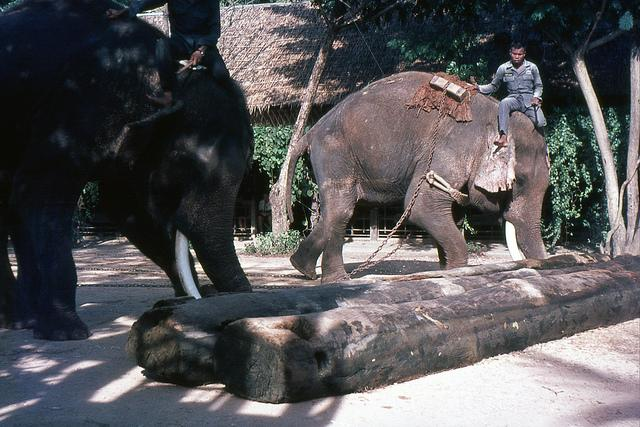What power will be used to move logs here?

Choices:
A) elephant
B) tractor
C) man power
D) boats elephant 